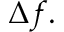Convert formula to latex. <formula><loc_0><loc_0><loc_500><loc_500>\Delta f .</formula> 